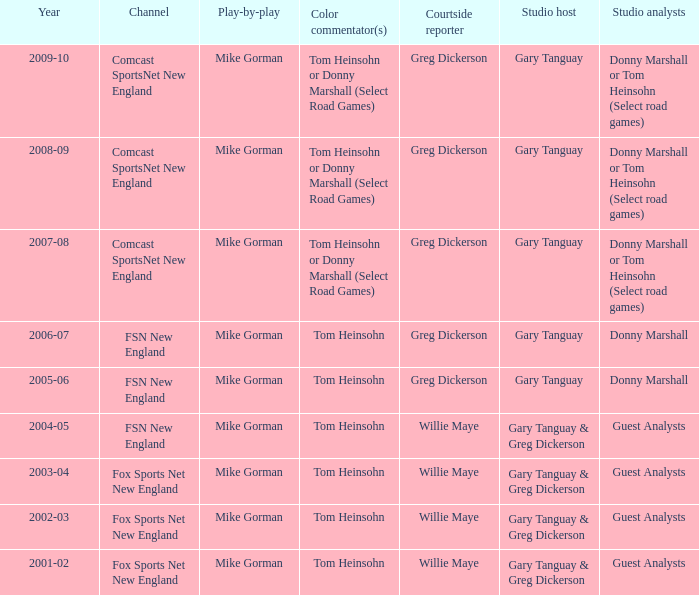Who are the studio analysts for the year 2008-09? Donny Marshall or Tom Heinsohn (Select road games). 